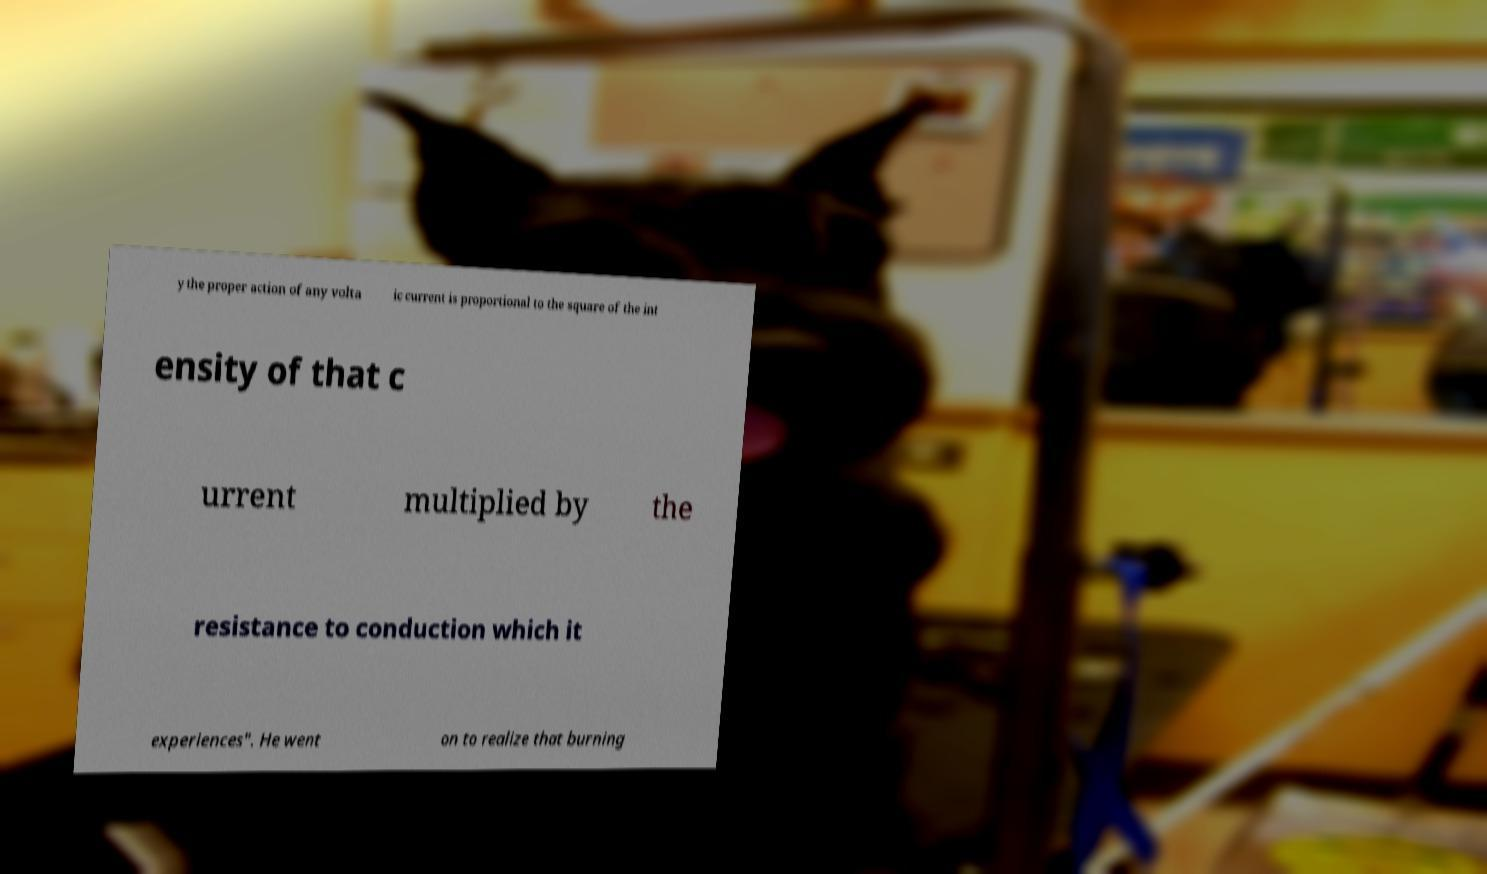What messages or text are displayed in this image? I need them in a readable, typed format. y the proper action of any volta ic current is proportional to the square of the int ensity of that c urrent multiplied by the resistance to conduction which it experiences". He went on to realize that burning 